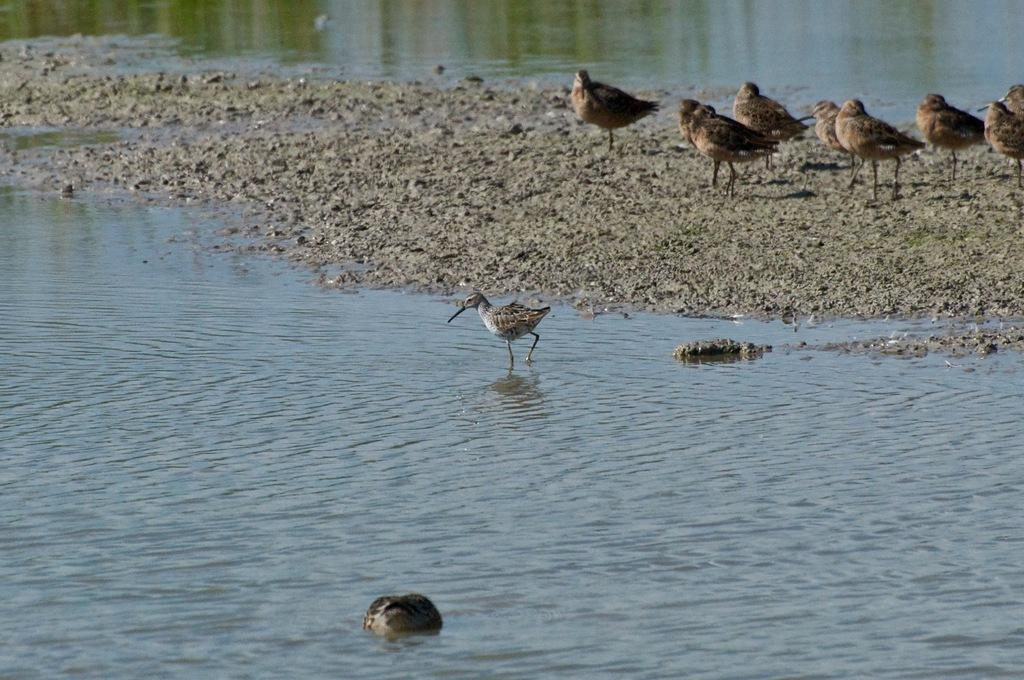What is the primary element visible in the image? There is water in the image. What else can be seen in the image besides water? There is ground visible in the image, as well as birds and an object in the water. What type of note can be seen floating in the water in the image? There is no note visible in the image; it only features water, ground, birds, and an object in the water. 